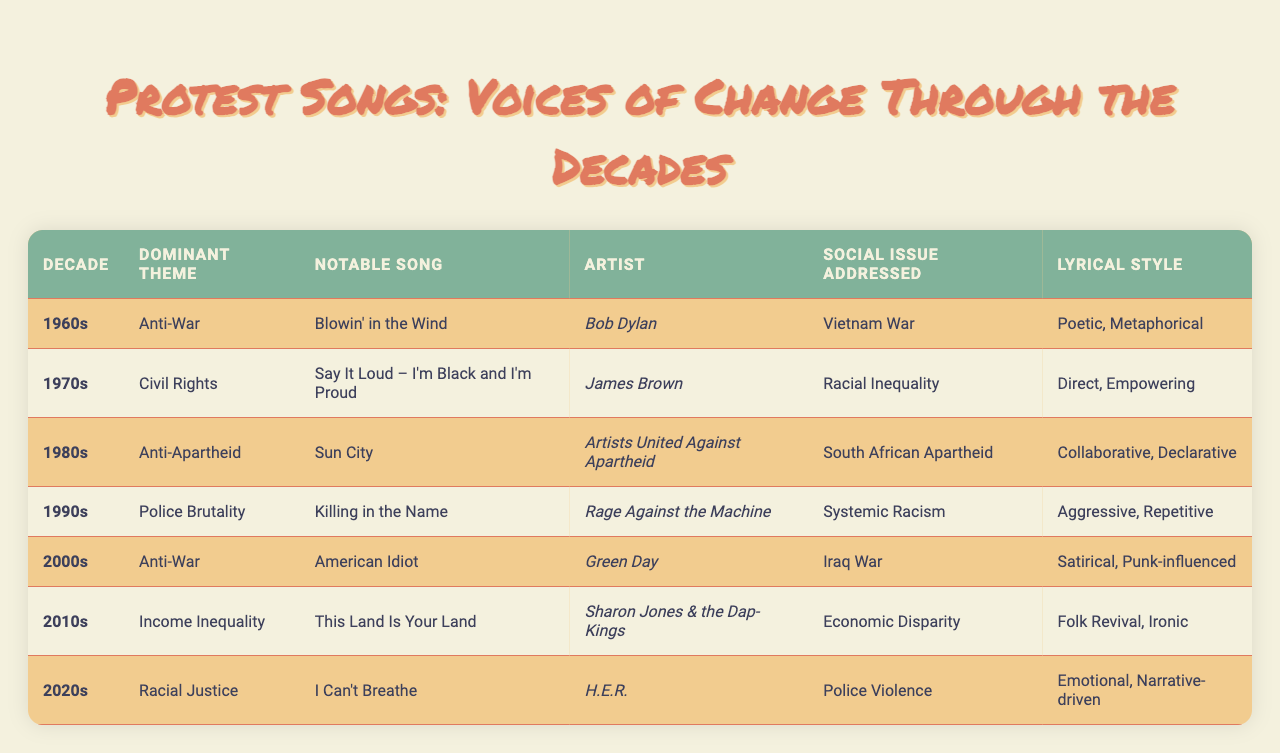What was the dominant theme in the 1970s? By checking the table under the 1970s row, the dominant theme listed is "Civil Rights."
Answer: Civil Rights Which artist performed "American Idiot"? The table identifies "Green Day" as the artist for the song "American Idiot."
Answer: Green Day How many decades feature "Anti-War" as a theme? By scanning the table, "Anti-War" appears in the 1960s and 2000s, totaling two instances across the decades.
Answer: 2 Was "This Land Is Your Land" associated with economic disparity? The table reveals "This Land Is Your Land" is listed under the 2010s and explicitly states the social issue addressed is "Economic Disparity," confirming it's true.
Answer: Yes Which decade had a notable song addressing "Systemic Racism"? Looking at the table, the 1990s shows "Killing in the Name" as the notable song addressing "Systemic Racism."
Answer: 1990s What lyrical style is associated with "Blowin' in the Wind"? According to the table, "Blowin' in the Wind" is described as having a "Poetic, Metaphorical" lyrical style.
Answer: Poetic, Metaphorical Which decade had "Racial Justice" as the dominant theme? The table indicates that the 2020s has "Racial Justice" as the dominant theme.
Answer: 2020s Identify the notable song from the 1980s and its addressing issue. By examining the 1980s row, the notable song "Sun City" addresses the issue of "South African Apartheid."
Answer: Sun City; South African Apartheid How many songs are associated with the theme of "Racial Inequality"? The only song listed in the table with the theme of "Racial Inequality" is "Say It Loud – I'm Black and I'm Proud" from the 1970s, therefore there is one song.
Answer: 1 Which lyrical styles are found in the 2010s and 2020s? In the 2010s, the lyrical style is "Folk Revival, Ironic," and in the 2020s, it's "Emotional, Narrative-driven," showing a shift in lyrical approach.
Answer: Folk Revival, Ironic; Emotional, Narrative-driven 